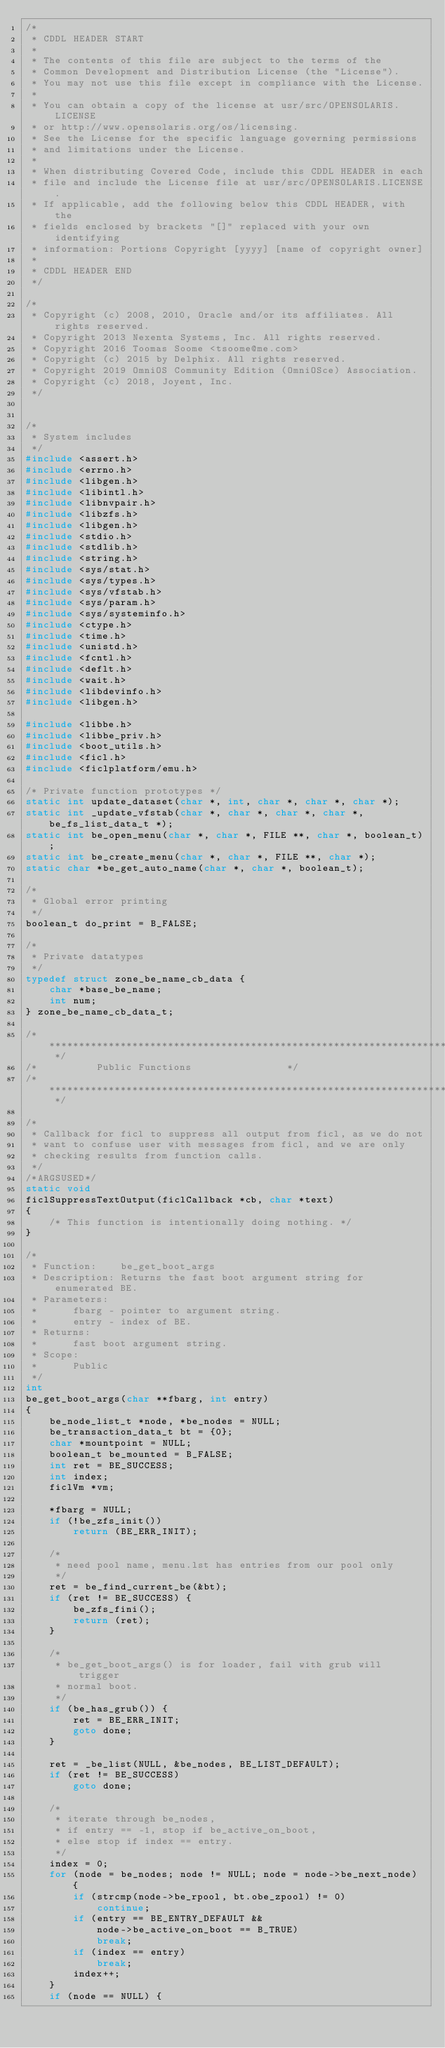<code> <loc_0><loc_0><loc_500><loc_500><_C_>/*
 * CDDL HEADER START
 *
 * The contents of this file are subject to the terms of the
 * Common Development and Distribution License (the "License").
 * You may not use this file except in compliance with the License.
 *
 * You can obtain a copy of the license at usr/src/OPENSOLARIS.LICENSE
 * or http://www.opensolaris.org/os/licensing.
 * See the License for the specific language governing permissions
 * and limitations under the License.
 *
 * When distributing Covered Code, include this CDDL HEADER in each
 * file and include the License file at usr/src/OPENSOLARIS.LICENSE.
 * If applicable, add the following below this CDDL HEADER, with the
 * fields enclosed by brackets "[]" replaced with your own identifying
 * information: Portions Copyright [yyyy] [name of copyright owner]
 *
 * CDDL HEADER END
 */

/*
 * Copyright (c) 2008, 2010, Oracle and/or its affiliates. All rights reserved.
 * Copyright 2013 Nexenta Systems, Inc. All rights reserved.
 * Copyright 2016 Toomas Soome <tsoome@me.com>
 * Copyright (c) 2015 by Delphix. All rights reserved.
 * Copyright 2019 OmniOS Community Edition (OmniOSce) Association.
 * Copyright (c) 2018, Joyent, Inc.
 */


/*
 * System includes
 */
#include <assert.h>
#include <errno.h>
#include <libgen.h>
#include <libintl.h>
#include <libnvpair.h>
#include <libzfs.h>
#include <libgen.h>
#include <stdio.h>
#include <stdlib.h>
#include <string.h>
#include <sys/stat.h>
#include <sys/types.h>
#include <sys/vfstab.h>
#include <sys/param.h>
#include <sys/systeminfo.h>
#include <ctype.h>
#include <time.h>
#include <unistd.h>
#include <fcntl.h>
#include <deflt.h>
#include <wait.h>
#include <libdevinfo.h>
#include <libgen.h>

#include <libbe.h>
#include <libbe_priv.h>
#include <boot_utils.h>
#include <ficl.h>
#include <ficlplatform/emu.h>

/* Private function prototypes */
static int update_dataset(char *, int, char *, char *, char *);
static int _update_vfstab(char *, char *, char *, char *, be_fs_list_data_t *);
static int be_open_menu(char *, char *, FILE **, char *, boolean_t);
static int be_create_menu(char *, char *, FILE **, char *);
static char *be_get_auto_name(char *, char *, boolean_t);

/*
 * Global error printing
 */
boolean_t do_print = B_FALSE;

/*
 * Private datatypes
 */
typedef struct zone_be_name_cb_data {
	char *base_be_name;
	int num;
} zone_be_name_cb_data_t;

/* ********************************************************************	*/
/*			Public Functions				*/
/* ******************************************************************** */

/*
 * Callback for ficl to suppress all output from ficl, as we do not
 * want to confuse user with messages from ficl, and we are only
 * checking results from function calls.
 */
/*ARGSUSED*/
static void
ficlSuppressTextOutput(ficlCallback *cb, char *text)
{
	/* This function is intentionally doing nothing. */
}

/*
 * Function:	be_get_boot_args
 * Description:	Returns the fast boot argument string for enumerated BE.
 * Parameters:
 *		fbarg - pointer to argument string.
 *		entry - index of BE.
 * Returns:
 *		fast boot argument string.
 * Scope:
 *		Public
 */
int
be_get_boot_args(char **fbarg, int entry)
{
	be_node_list_t *node, *be_nodes = NULL;
	be_transaction_data_t bt = {0};
	char *mountpoint = NULL;
	boolean_t be_mounted = B_FALSE;
	int ret = BE_SUCCESS;
	int index;
	ficlVm *vm;

	*fbarg = NULL;
	if (!be_zfs_init())
		return (BE_ERR_INIT);

	/*
	 * need pool name, menu.lst has entries from our pool only
	 */
	ret = be_find_current_be(&bt);
	if (ret != BE_SUCCESS) {
		be_zfs_fini();
		return (ret);
	}

	/*
	 * be_get_boot_args() is for loader, fail with grub will trigger
	 * normal boot.
	 */
	if (be_has_grub()) {
		ret = BE_ERR_INIT;
		goto done;
	}

	ret = _be_list(NULL, &be_nodes, BE_LIST_DEFAULT);
	if (ret != BE_SUCCESS)
		goto done;

	/*
	 * iterate through be_nodes,
	 * if entry == -1, stop if be_active_on_boot,
	 * else stop if index == entry.
	 */
	index = 0;
	for (node = be_nodes; node != NULL; node = node->be_next_node) {
		if (strcmp(node->be_rpool, bt.obe_zpool) != 0)
			continue;
		if (entry == BE_ENTRY_DEFAULT &&
		    node->be_active_on_boot == B_TRUE)
			break;
		if (index == entry)
			break;
		index++;
	}
	if (node == NULL) {</code> 